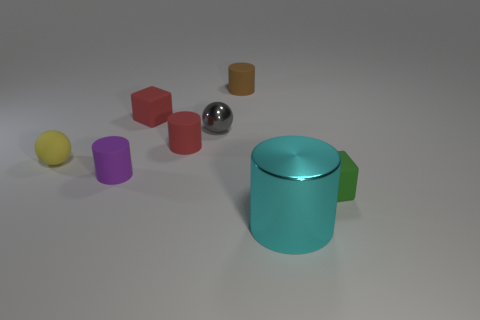What size is the yellow matte object that is behind the cyan shiny cylinder?
Ensure brevity in your answer.  Small. There is a small green thing; is its shape the same as the tiny red matte object behind the tiny gray metallic ball?
Your answer should be compact. Yes. Is the number of green things behind the green matte cube less than the number of red rubber objects that are on the right side of the red cube?
Provide a short and direct response. Yes. What is the material of the other object that is the same shape as the yellow matte object?
Your answer should be compact. Metal. What is the shape of the green object that is the same material as the small red cube?
Offer a very short reply. Cube. How many other small yellow objects are the same shape as the small yellow rubber thing?
Make the answer very short. 0. What is the shape of the shiny object behind the cyan shiny object in front of the green rubber cube?
Give a very brief answer. Sphere. There is a sphere that is behind the yellow thing; is it the same size as the tiny yellow object?
Provide a short and direct response. Yes. There is a object that is both left of the small green rubber object and on the right side of the brown object; what is its size?
Your answer should be very brief. Large. What number of brown things are the same size as the shiny sphere?
Offer a very short reply. 1. 